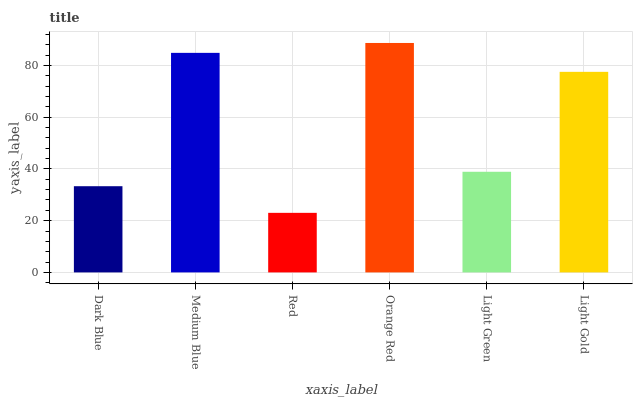Is Red the minimum?
Answer yes or no. Yes. Is Orange Red the maximum?
Answer yes or no. Yes. Is Medium Blue the minimum?
Answer yes or no. No. Is Medium Blue the maximum?
Answer yes or no. No. Is Medium Blue greater than Dark Blue?
Answer yes or no. Yes. Is Dark Blue less than Medium Blue?
Answer yes or no. Yes. Is Dark Blue greater than Medium Blue?
Answer yes or no. No. Is Medium Blue less than Dark Blue?
Answer yes or no. No. Is Light Gold the high median?
Answer yes or no. Yes. Is Light Green the low median?
Answer yes or no. Yes. Is Orange Red the high median?
Answer yes or no. No. Is Light Gold the low median?
Answer yes or no. No. 